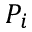<formula> <loc_0><loc_0><loc_500><loc_500>P _ { i }</formula> 